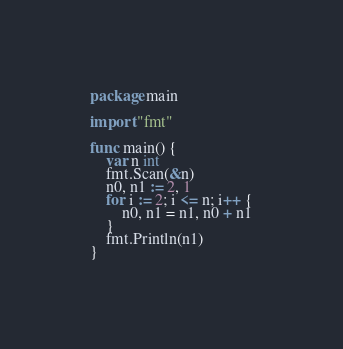Convert code to text. <code><loc_0><loc_0><loc_500><loc_500><_Go_>package main

import "fmt"

func main() {
	var n int
	fmt.Scan(&n)
	n0, n1 := 2, 1
	for i := 2; i <= n; i++ {
		n0, n1 = n1, n0 + n1
	}
	fmt.Println(n1)
}
</code> 